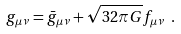Convert formula to latex. <formula><loc_0><loc_0><loc_500><loc_500>g _ { \mu \nu } = \bar { g } _ { \mu \nu } + \sqrt { 3 2 \pi G } f _ { \mu \nu } \ .</formula> 